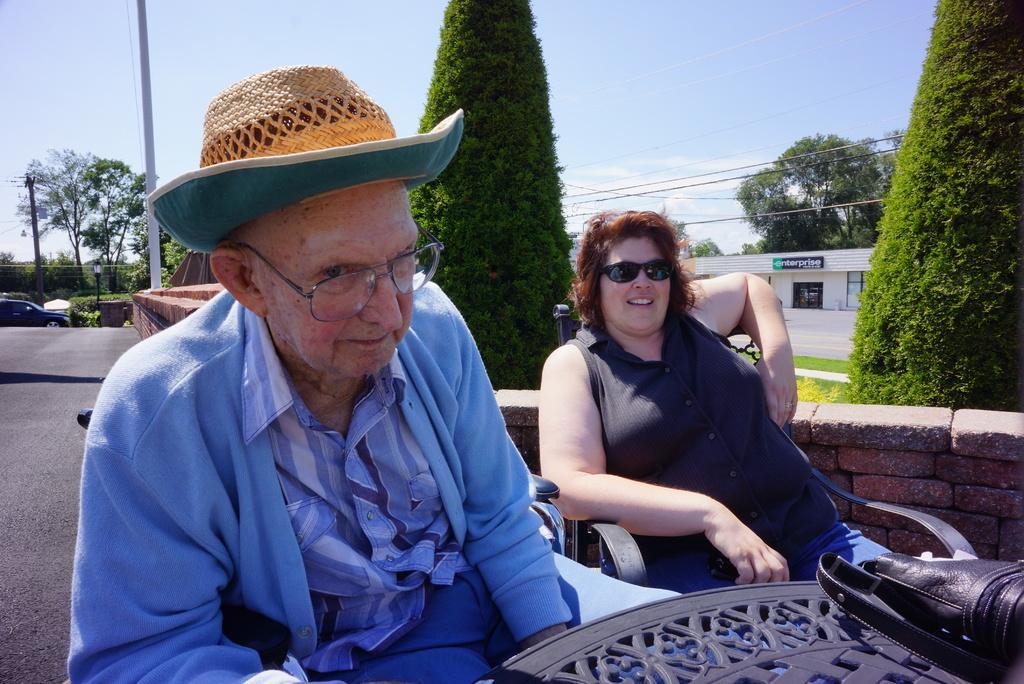In one or two sentences, can you explain what this image depicts? In this image there is a woman and a man sitting on chairs, in front of them there is a table, on that table there is a bag, behind the women there is a wall and trees, in the background there is a building trees pole and a sky. 